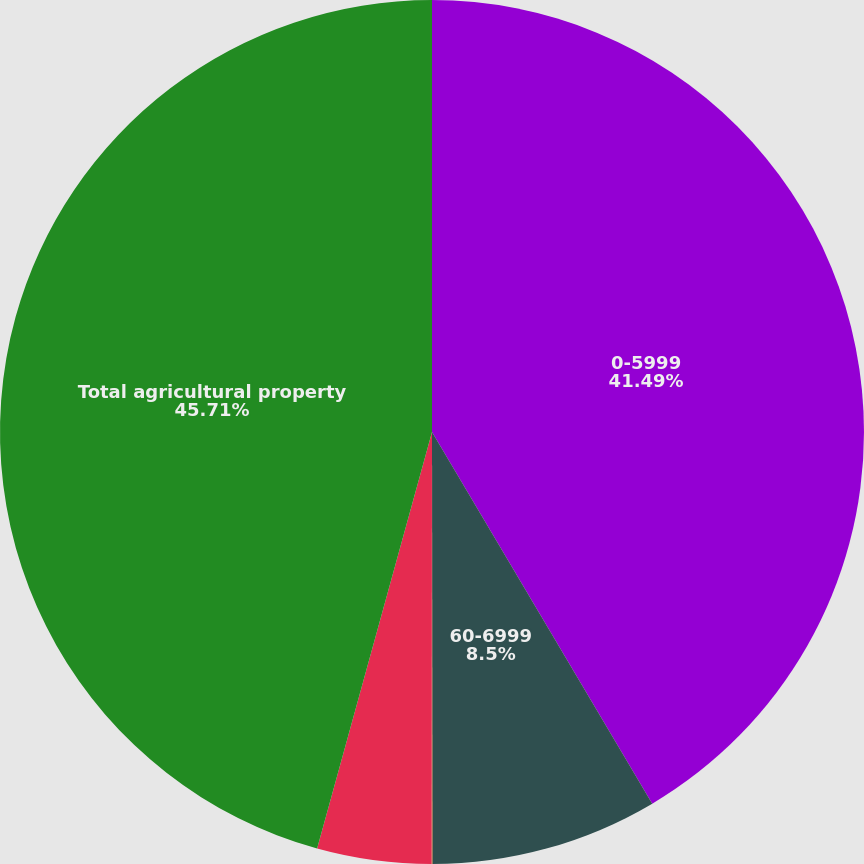<chart> <loc_0><loc_0><loc_500><loc_500><pie_chart><fcel>0-5999<fcel>60-6999<fcel>70-7999<fcel>80 or greater<fcel>Total agricultural property<nl><fcel>41.49%<fcel>8.5%<fcel>0.03%<fcel>4.27%<fcel>45.72%<nl></chart> 